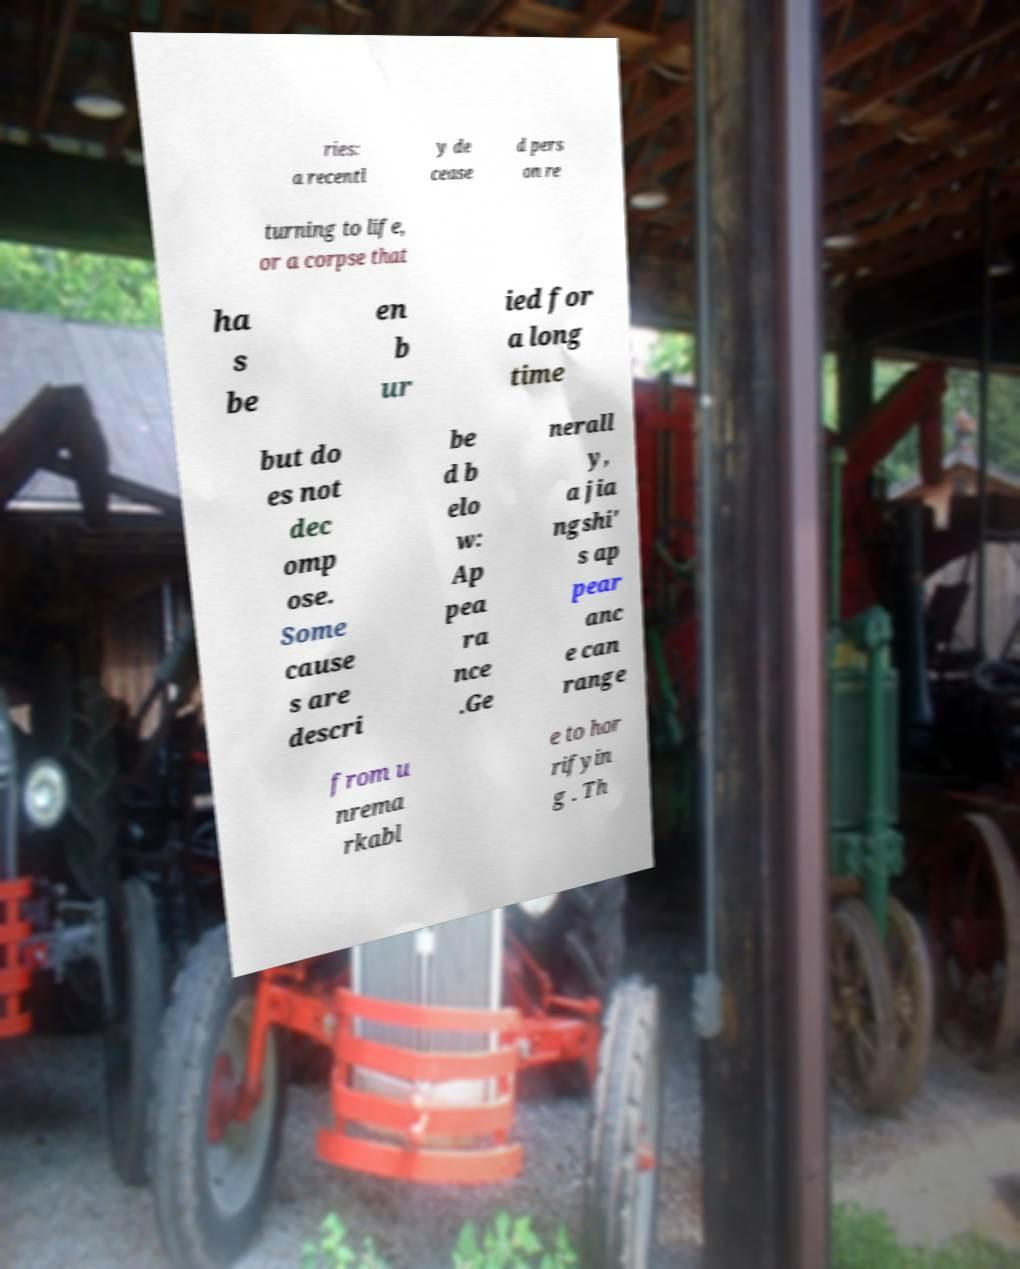I need the written content from this picture converted into text. Can you do that? ries: a recentl y de cease d pers on re turning to life, or a corpse that ha s be en b ur ied for a long time but do es not dec omp ose. Some cause s are descri be d b elo w: Ap pea ra nce .Ge nerall y, a jia ngshi' s ap pear anc e can range from u nrema rkabl e to hor rifyin g . Th 